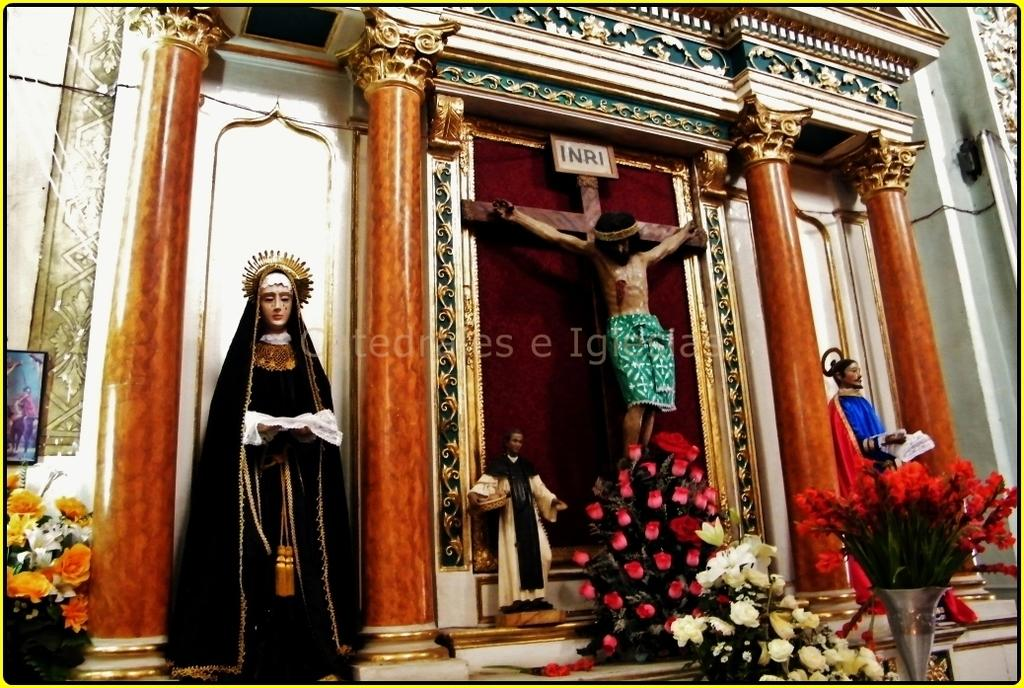<image>
Write a terse but informative summary of the picture. A scene with Jesus on a cross and INRI written above his head. 